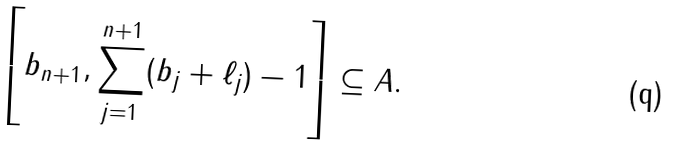<formula> <loc_0><loc_0><loc_500><loc_500>\left [ b _ { n + 1 } , \sum _ { j = 1 } ^ { n + 1 } ( b _ { j } + \ell _ { j } ) - 1 \right ] \subseteq A .</formula> 